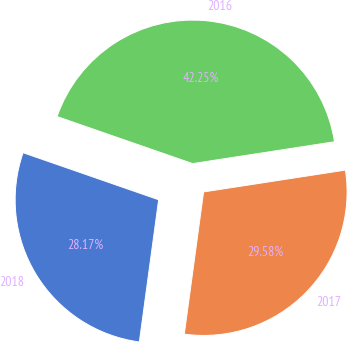Convert chart to OTSL. <chart><loc_0><loc_0><loc_500><loc_500><pie_chart><fcel>2018<fcel>2017<fcel>2016<nl><fcel>28.17%<fcel>29.58%<fcel>42.25%<nl></chart> 